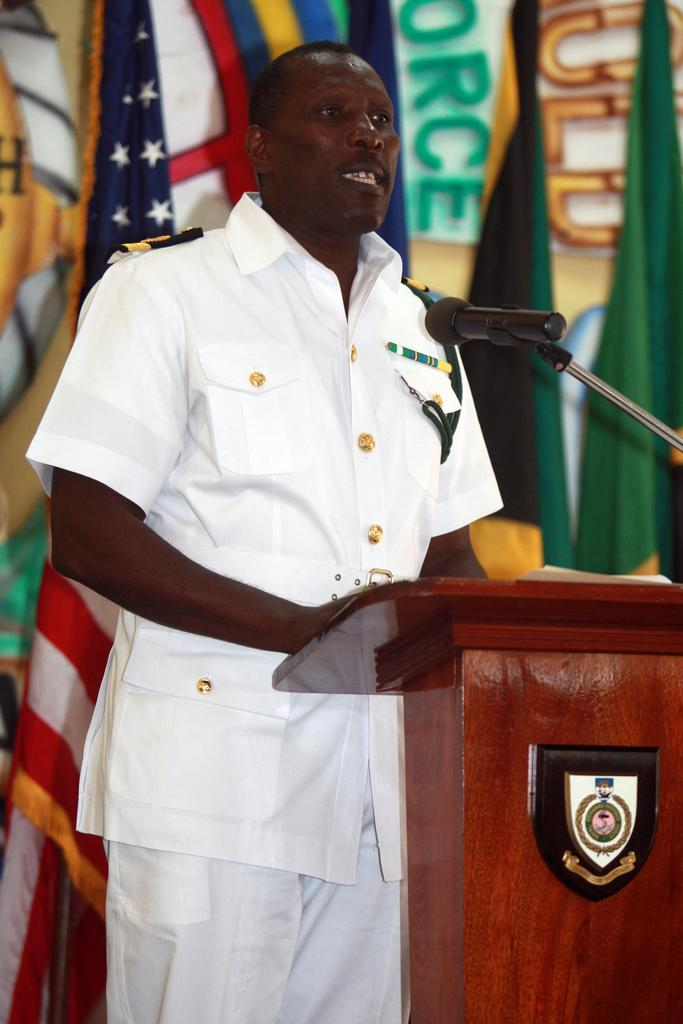What is the main subject of the image? There is a person in the image. What is the person wearing? The person is wearing a white dress. What is in front of the person? There is a podium in front of the person. What is on the podium? Papers and a microphone are present on the podium. What can be seen in the background of the image? Flags are visible in the background of the image. What is the best route to take to avoid the doctor in the image? There is no doctor present in the image, so there is no need to avoid one. 